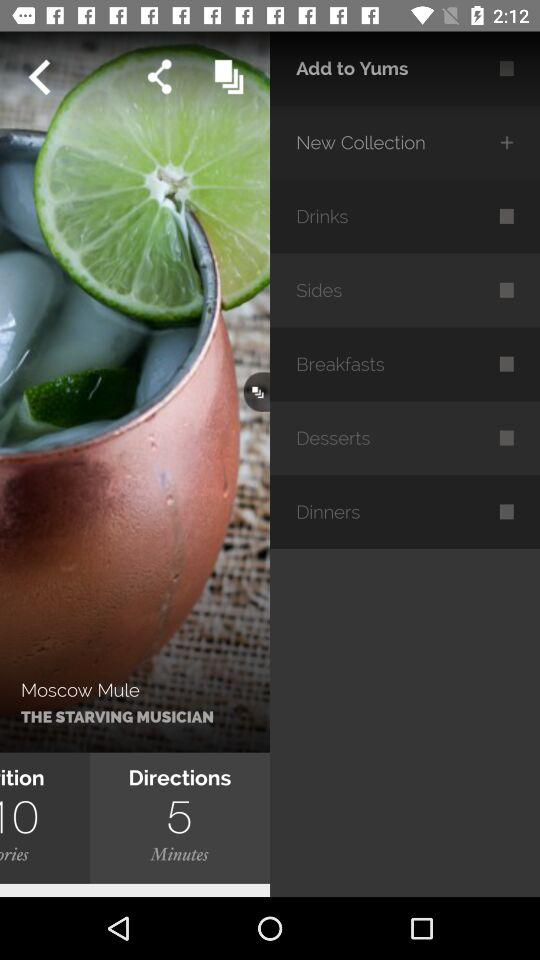How long will it take to prepare the drink? It will take 5 minutes to prepare the drink. 